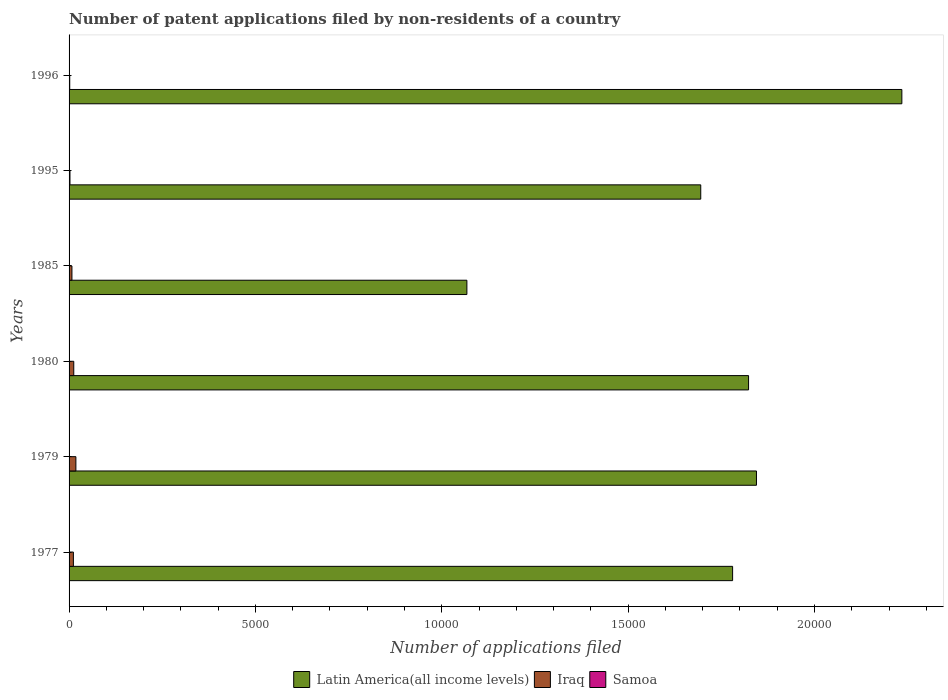Are the number of bars on each tick of the Y-axis equal?
Offer a very short reply. Yes. How many bars are there on the 6th tick from the top?
Make the answer very short. 3. What is the label of the 4th group of bars from the top?
Offer a very short reply. 1980. What is the number of applications filed in Iraq in 1980?
Ensure brevity in your answer.  126. In which year was the number of applications filed in Samoa maximum?
Your answer should be very brief. 1979. What is the total number of applications filed in Latin America(all income levels) in the graph?
Offer a very short reply. 1.04e+05. What is the difference between the number of applications filed in Iraq in 1977 and the number of applications filed in Latin America(all income levels) in 1995?
Your answer should be very brief. -1.68e+04. What is the average number of applications filed in Iraq per year?
Your answer should be very brief. 90.67. In the year 1995, what is the difference between the number of applications filed in Iraq and number of applications filed in Samoa?
Ensure brevity in your answer.  22. In how many years, is the number of applications filed in Samoa greater than 13000 ?
Ensure brevity in your answer.  0. What is the difference between the highest and the second highest number of applications filed in Samoa?
Offer a very short reply. 0. What is the difference between the highest and the lowest number of applications filed in Iraq?
Ensure brevity in your answer.  165. Is the sum of the number of applications filed in Iraq in 1979 and 1980 greater than the maximum number of applications filed in Samoa across all years?
Offer a very short reply. Yes. What does the 3rd bar from the top in 1977 represents?
Offer a very short reply. Latin America(all income levels). What does the 1st bar from the bottom in 1985 represents?
Offer a very short reply. Latin America(all income levels). How many bars are there?
Provide a short and direct response. 18. Are all the bars in the graph horizontal?
Provide a succinct answer. Yes. How many years are there in the graph?
Keep it short and to the point. 6. What is the title of the graph?
Give a very brief answer. Number of patent applications filed by non-residents of a country. What is the label or title of the X-axis?
Make the answer very short. Number of applications filed. What is the label or title of the Y-axis?
Offer a terse response. Years. What is the Number of applications filed in Latin America(all income levels) in 1977?
Provide a succinct answer. 1.78e+04. What is the Number of applications filed of Iraq in 1977?
Your answer should be compact. 116. What is the Number of applications filed in Latin America(all income levels) in 1979?
Make the answer very short. 1.84e+04. What is the Number of applications filed in Iraq in 1979?
Provide a short and direct response. 183. What is the Number of applications filed in Latin America(all income levels) in 1980?
Your answer should be compact. 1.82e+04. What is the Number of applications filed of Iraq in 1980?
Your response must be concise. 126. What is the Number of applications filed of Samoa in 1980?
Give a very brief answer. 2. What is the Number of applications filed of Latin America(all income levels) in 1985?
Provide a succinct answer. 1.07e+04. What is the Number of applications filed in Iraq in 1985?
Your answer should be very brief. 77. What is the Number of applications filed in Latin America(all income levels) in 1995?
Keep it short and to the point. 1.69e+04. What is the Number of applications filed of Iraq in 1995?
Give a very brief answer. 24. What is the Number of applications filed of Latin America(all income levels) in 1996?
Make the answer very short. 2.23e+04. Across all years, what is the maximum Number of applications filed in Latin America(all income levels)?
Your response must be concise. 2.23e+04. Across all years, what is the maximum Number of applications filed of Iraq?
Give a very brief answer. 183. Across all years, what is the maximum Number of applications filed of Samoa?
Offer a terse response. 4. Across all years, what is the minimum Number of applications filed in Latin America(all income levels)?
Provide a short and direct response. 1.07e+04. Across all years, what is the minimum Number of applications filed in Iraq?
Ensure brevity in your answer.  18. Across all years, what is the minimum Number of applications filed of Samoa?
Provide a short and direct response. 2. What is the total Number of applications filed in Latin America(all income levels) in the graph?
Provide a succinct answer. 1.04e+05. What is the total Number of applications filed of Iraq in the graph?
Your response must be concise. 544. What is the total Number of applications filed of Samoa in the graph?
Your answer should be very brief. 18. What is the difference between the Number of applications filed of Latin America(all income levels) in 1977 and that in 1979?
Offer a terse response. -640. What is the difference between the Number of applications filed of Iraq in 1977 and that in 1979?
Provide a succinct answer. -67. What is the difference between the Number of applications filed of Samoa in 1977 and that in 1979?
Provide a succinct answer. -1. What is the difference between the Number of applications filed in Latin America(all income levels) in 1977 and that in 1980?
Make the answer very short. -428. What is the difference between the Number of applications filed in Samoa in 1977 and that in 1980?
Give a very brief answer. 1. What is the difference between the Number of applications filed in Latin America(all income levels) in 1977 and that in 1985?
Offer a very short reply. 7130. What is the difference between the Number of applications filed of Iraq in 1977 and that in 1985?
Ensure brevity in your answer.  39. What is the difference between the Number of applications filed of Latin America(all income levels) in 1977 and that in 1995?
Your response must be concise. 855. What is the difference between the Number of applications filed of Iraq in 1977 and that in 1995?
Give a very brief answer. 92. What is the difference between the Number of applications filed in Samoa in 1977 and that in 1995?
Provide a short and direct response. 1. What is the difference between the Number of applications filed in Latin America(all income levels) in 1977 and that in 1996?
Ensure brevity in your answer.  -4541. What is the difference between the Number of applications filed in Latin America(all income levels) in 1979 and that in 1980?
Give a very brief answer. 212. What is the difference between the Number of applications filed of Samoa in 1979 and that in 1980?
Your answer should be compact. 2. What is the difference between the Number of applications filed of Latin America(all income levels) in 1979 and that in 1985?
Your response must be concise. 7770. What is the difference between the Number of applications filed in Iraq in 1979 and that in 1985?
Your answer should be very brief. 106. What is the difference between the Number of applications filed in Samoa in 1979 and that in 1985?
Your answer should be compact. 0. What is the difference between the Number of applications filed of Latin America(all income levels) in 1979 and that in 1995?
Give a very brief answer. 1495. What is the difference between the Number of applications filed of Iraq in 1979 and that in 1995?
Your response must be concise. 159. What is the difference between the Number of applications filed in Latin America(all income levels) in 1979 and that in 1996?
Your answer should be very brief. -3901. What is the difference between the Number of applications filed in Iraq in 1979 and that in 1996?
Provide a succinct answer. 165. What is the difference between the Number of applications filed in Latin America(all income levels) in 1980 and that in 1985?
Provide a succinct answer. 7558. What is the difference between the Number of applications filed of Samoa in 1980 and that in 1985?
Your answer should be very brief. -2. What is the difference between the Number of applications filed of Latin America(all income levels) in 1980 and that in 1995?
Offer a very short reply. 1283. What is the difference between the Number of applications filed of Iraq in 1980 and that in 1995?
Your answer should be compact. 102. What is the difference between the Number of applications filed of Samoa in 1980 and that in 1995?
Keep it short and to the point. 0. What is the difference between the Number of applications filed in Latin America(all income levels) in 1980 and that in 1996?
Offer a terse response. -4113. What is the difference between the Number of applications filed in Iraq in 1980 and that in 1996?
Give a very brief answer. 108. What is the difference between the Number of applications filed in Samoa in 1980 and that in 1996?
Provide a succinct answer. -1. What is the difference between the Number of applications filed of Latin America(all income levels) in 1985 and that in 1995?
Your response must be concise. -6275. What is the difference between the Number of applications filed of Iraq in 1985 and that in 1995?
Your answer should be very brief. 53. What is the difference between the Number of applications filed of Latin America(all income levels) in 1985 and that in 1996?
Ensure brevity in your answer.  -1.17e+04. What is the difference between the Number of applications filed of Iraq in 1985 and that in 1996?
Give a very brief answer. 59. What is the difference between the Number of applications filed of Latin America(all income levels) in 1995 and that in 1996?
Your response must be concise. -5396. What is the difference between the Number of applications filed in Iraq in 1995 and that in 1996?
Provide a short and direct response. 6. What is the difference between the Number of applications filed of Samoa in 1995 and that in 1996?
Provide a succinct answer. -1. What is the difference between the Number of applications filed in Latin America(all income levels) in 1977 and the Number of applications filed in Iraq in 1979?
Keep it short and to the point. 1.76e+04. What is the difference between the Number of applications filed in Latin America(all income levels) in 1977 and the Number of applications filed in Samoa in 1979?
Offer a terse response. 1.78e+04. What is the difference between the Number of applications filed of Iraq in 1977 and the Number of applications filed of Samoa in 1979?
Ensure brevity in your answer.  112. What is the difference between the Number of applications filed of Latin America(all income levels) in 1977 and the Number of applications filed of Iraq in 1980?
Offer a terse response. 1.77e+04. What is the difference between the Number of applications filed of Latin America(all income levels) in 1977 and the Number of applications filed of Samoa in 1980?
Ensure brevity in your answer.  1.78e+04. What is the difference between the Number of applications filed of Iraq in 1977 and the Number of applications filed of Samoa in 1980?
Provide a short and direct response. 114. What is the difference between the Number of applications filed of Latin America(all income levels) in 1977 and the Number of applications filed of Iraq in 1985?
Offer a terse response. 1.77e+04. What is the difference between the Number of applications filed of Latin America(all income levels) in 1977 and the Number of applications filed of Samoa in 1985?
Your answer should be compact. 1.78e+04. What is the difference between the Number of applications filed in Iraq in 1977 and the Number of applications filed in Samoa in 1985?
Provide a short and direct response. 112. What is the difference between the Number of applications filed of Latin America(all income levels) in 1977 and the Number of applications filed of Iraq in 1995?
Provide a succinct answer. 1.78e+04. What is the difference between the Number of applications filed of Latin America(all income levels) in 1977 and the Number of applications filed of Samoa in 1995?
Give a very brief answer. 1.78e+04. What is the difference between the Number of applications filed in Iraq in 1977 and the Number of applications filed in Samoa in 1995?
Keep it short and to the point. 114. What is the difference between the Number of applications filed of Latin America(all income levels) in 1977 and the Number of applications filed of Iraq in 1996?
Provide a short and direct response. 1.78e+04. What is the difference between the Number of applications filed in Latin America(all income levels) in 1977 and the Number of applications filed in Samoa in 1996?
Offer a very short reply. 1.78e+04. What is the difference between the Number of applications filed of Iraq in 1977 and the Number of applications filed of Samoa in 1996?
Your answer should be very brief. 113. What is the difference between the Number of applications filed of Latin America(all income levels) in 1979 and the Number of applications filed of Iraq in 1980?
Your answer should be very brief. 1.83e+04. What is the difference between the Number of applications filed in Latin America(all income levels) in 1979 and the Number of applications filed in Samoa in 1980?
Provide a succinct answer. 1.84e+04. What is the difference between the Number of applications filed of Iraq in 1979 and the Number of applications filed of Samoa in 1980?
Your answer should be very brief. 181. What is the difference between the Number of applications filed of Latin America(all income levels) in 1979 and the Number of applications filed of Iraq in 1985?
Your response must be concise. 1.84e+04. What is the difference between the Number of applications filed in Latin America(all income levels) in 1979 and the Number of applications filed in Samoa in 1985?
Your answer should be compact. 1.84e+04. What is the difference between the Number of applications filed of Iraq in 1979 and the Number of applications filed of Samoa in 1985?
Make the answer very short. 179. What is the difference between the Number of applications filed in Latin America(all income levels) in 1979 and the Number of applications filed in Iraq in 1995?
Offer a very short reply. 1.84e+04. What is the difference between the Number of applications filed in Latin America(all income levels) in 1979 and the Number of applications filed in Samoa in 1995?
Give a very brief answer. 1.84e+04. What is the difference between the Number of applications filed of Iraq in 1979 and the Number of applications filed of Samoa in 1995?
Provide a short and direct response. 181. What is the difference between the Number of applications filed in Latin America(all income levels) in 1979 and the Number of applications filed in Iraq in 1996?
Give a very brief answer. 1.84e+04. What is the difference between the Number of applications filed in Latin America(all income levels) in 1979 and the Number of applications filed in Samoa in 1996?
Give a very brief answer. 1.84e+04. What is the difference between the Number of applications filed in Iraq in 1979 and the Number of applications filed in Samoa in 1996?
Ensure brevity in your answer.  180. What is the difference between the Number of applications filed of Latin America(all income levels) in 1980 and the Number of applications filed of Iraq in 1985?
Your answer should be very brief. 1.82e+04. What is the difference between the Number of applications filed in Latin America(all income levels) in 1980 and the Number of applications filed in Samoa in 1985?
Offer a terse response. 1.82e+04. What is the difference between the Number of applications filed of Iraq in 1980 and the Number of applications filed of Samoa in 1985?
Provide a succinct answer. 122. What is the difference between the Number of applications filed of Latin America(all income levels) in 1980 and the Number of applications filed of Iraq in 1995?
Offer a terse response. 1.82e+04. What is the difference between the Number of applications filed of Latin America(all income levels) in 1980 and the Number of applications filed of Samoa in 1995?
Offer a very short reply. 1.82e+04. What is the difference between the Number of applications filed of Iraq in 1980 and the Number of applications filed of Samoa in 1995?
Your answer should be compact. 124. What is the difference between the Number of applications filed of Latin America(all income levels) in 1980 and the Number of applications filed of Iraq in 1996?
Your response must be concise. 1.82e+04. What is the difference between the Number of applications filed in Latin America(all income levels) in 1980 and the Number of applications filed in Samoa in 1996?
Provide a succinct answer. 1.82e+04. What is the difference between the Number of applications filed in Iraq in 1980 and the Number of applications filed in Samoa in 1996?
Offer a very short reply. 123. What is the difference between the Number of applications filed in Latin America(all income levels) in 1985 and the Number of applications filed in Iraq in 1995?
Provide a succinct answer. 1.06e+04. What is the difference between the Number of applications filed of Latin America(all income levels) in 1985 and the Number of applications filed of Samoa in 1995?
Provide a short and direct response. 1.07e+04. What is the difference between the Number of applications filed of Latin America(all income levels) in 1985 and the Number of applications filed of Iraq in 1996?
Ensure brevity in your answer.  1.07e+04. What is the difference between the Number of applications filed in Latin America(all income levels) in 1985 and the Number of applications filed in Samoa in 1996?
Provide a succinct answer. 1.07e+04. What is the difference between the Number of applications filed in Latin America(all income levels) in 1995 and the Number of applications filed in Iraq in 1996?
Your answer should be very brief. 1.69e+04. What is the difference between the Number of applications filed of Latin America(all income levels) in 1995 and the Number of applications filed of Samoa in 1996?
Offer a very short reply. 1.69e+04. What is the difference between the Number of applications filed of Iraq in 1995 and the Number of applications filed of Samoa in 1996?
Offer a terse response. 21. What is the average Number of applications filed of Latin America(all income levels) per year?
Offer a very short reply. 1.74e+04. What is the average Number of applications filed of Iraq per year?
Ensure brevity in your answer.  90.67. In the year 1977, what is the difference between the Number of applications filed in Latin America(all income levels) and Number of applications filed in Iraq?
Provide a succinct answer. 1.77e+04. In the year 1977, what is the difference between the Number of applications filed in Latin America(all income levels) and Number of applications filed in Samoa?
Provide a short and direct response. 1.78e+04. In the year 1977, what is the difference between the Number of applications filed in Iraq and Number of applications filed in Samoa?
Your answer should be very brief. 113. In the year 1979, what is the difference between the Number of applications filed in Latin America(all income levels) and Number of applications filed in Iraq?
Your answer should be compact. 1.83e+04. In the year 1979, what is the difference between the Number of applications filed in Latin America(all income levels) and Number of applications filed in Samoa?
Your answer should be compact. 1.84e+04. In the year 1979, what is the difference between the Number of applications filed in Iraq and Number of applications filed in Samoa?
Offer a terse response. 179. In the year 1980, what is the difference between the Number of applications filed in Latin America(all income levels) and Number of applications filed in Iraq?
Provide a succinct answer. 1.81e+04. In the year 1980, what is the difference between the Number of applications filed in Latin America(all income levels) and Number of applications filed in Samoa?
Offer a very short reply. 1.82e+04. In the year 1980, what is the difference between the Number of applications filed of Iraq and Number of applications filed of Samoa?
Ensure brevity in your answer.  124. In the year 1985, what is the difference between the Number of applications filed of Latin America(all income levels) and Number of applications filed of Iraq?
Give a very brief answer. 1.06e+04. In the year 1985, what is the difference between the Number of applications filed in Latin America(all income levels) and Number of applications filed in Samoa?
Offer a very short reply. 1.07e+04. In the year 1985, what is the difference between the Number of applications filed of Iraq and Number of applications filed of Samoa?
Your response must be concise. 73. In the year 1995, what is the difference between the Number of applications filed of Latin America(all income levels) and Number of applications filed of Iraq?
Your answer should be compact. 1.69e+04. In the year 1995, what is the difference between the Number of applications filed of Latin America(all income levels) and Number of applications filed of Samoa?
Your answer should be very brief. 1.69e+04. In the year 1995, what is the difference between the Number of applications filed in Iraq and Number of applications filed in Samoa?
Your answer should be compact. 22. In the year 1996, what is the difference between the Number of applications filed in Latin America(all income levels) and Number of applications filed in Iraq?
Your answer should be very brief. 2.23e+04. In the year 1996, what is the difference between the Number of applications filed in Latin America(all income levels) and Number of applications filed in Samoa?
Offer a very short reply. 2.23e+04. What is the ratio of the Number of applications filed in Latin America(all income levels) in 1977 to that in 1979?
Provide a succinct answer. 0.97. What is the ratio of the Number of applications filed in Iraq in 1977 to that in 1979?
Keep it short and to the point. 0.63. What is the ratio of the Number of applications filed in Latin America(all income levels) in 1977 to that in 1980?
Give a very brief answer. 0.98. What is the ratio of the Number of applications filed in Iraq in 1977 to that in 1980?
Offer a terse response. 0.92. What is the ratio of the Number of applications filed of Samoa in 1977 to that in 1980?
Ensure brevity in your answer.  1.5. What is the ratio of the Number of applications filed in Latin America(all income levels) in 1977 to that in 1985?
Offer a terse response. 1.67. What is the ratio of the Number of applications filed of Iraq in 1977 to that in 1985?
Provide a short and direct response. 1.51. What is the ratio of the Number of applications filed of Latin America(all income levels) in 1977 to that in 1995?
Make the answer very short. 1.05. What is the ratio of the Number of applications filed in Iraq in 1977 to that in 1995?
Your response must be concise. 4.83. What is the ratio of the Number of applications filed of Samoa in 1977 to that in 1995?
Provide a short and direct response. 1.5. What is the ratio of the Number of applications filed in Latin America(all income levels) in 1977 to that in 1996?
Your answer should be very brief. 0.8. What is the ratio of the Number of applications filed in Iraq in 1977 to that in 1996?
Ensure brevity in your answer.  6.44. What is the ratio of the Number of applications filed in Latin America(all income levels) in 1979 to that in 1980?
Offer a terse response. 1.01. What is the ratio of the Number of applications filed in Iraq in 1979 to that in 1980?
Give a very brief answer. 1.45. What is the ratio of the Number of applications filed of Latin America(all income levels) in 1979 to that in 1985?
Your response must be concise. 1.73. What is the ratio of the Number of applications filed in Iraq in 1979 to that in 1985?
Give a very brief answer. 2.38. What is the ratio of the Number of applications filed in Latin America(all income levels) in 1979 to that in 1995?
Make the answer very short. 1.09. What is the ratio of the Number of applications filed in Iraq in 1979 to that in 1995?
Your answer should be very brief. 7.62. What is the ratio of the Number of applications filed in Latin America(all income levels) in 1979 to that in 1996?
Your answer should be compact. 0.83. What is the ratio of the Number of applications filed in Iraq in 1979 to that in 1996?
Provide a short and direct response. 10.17. What is the ratio of the Number of applications filed of Samoa in 1979 to that in 1996?
Your answer should be compact. 1.33. What is the ratio of the Number of applications filed in Latin America(all income levels) in 1980 to that in 1985?
Make the answer very short. 1.71. What is the ratio of the Number of applications filed in Iraq in 1980 to that in 1985?
Provide a short and direct response. 1.64. What is the ratio of the Number of applications filed in Latin America(all income levels) in 1980 to that in 1995?
Provide a succinct answer. 1.08. What is the ratio of the Number of applications filed in Iraq in 1980 to that in 1995?
Provide a short and direct response. 5.25. What is the ratio of the Number of applications filed in Samoa in 1980 to that in 1995?
Your answer should be very brief. 1. What is the ratio of the Number of applications filed in Latin America(all income levels) in 1980 to that in 1996?
Your response must be concise. 0.82. What is the ratio of the Number of applications filed of Iraq in 1980 to that in 1996?
Offer a very short reply. 7. What is the ratio of the Number of applications filed of Latin America(all income levels) in 1985 to that in 1995?
Your answer should be very brief. 0.63. What is the ratio of the Number of applications filed in Iraq in 1985 to that in 1995?
Provide a short and direct response. 3.21. What is the ratio of the Number of applications filed in Latin America(all income levels) in 1985 to that in 1996?
Your answer should be very brief. 0.48. What is the ratio of the Number of applications filed in Iraq in 1985 to that in 1996?
Your answer should be compact. 4.28. What is the ratio of the Number of applications filed of Samoa in 1985 to that in 1996?
Ensure brevity in your answer.  1.33. What is the ratio of the Number of applications filed in Latin America(all income levels) in 1995 to that in 1996?
Give a very brief answer. 0.76. What is the ratio of the Number of applications filed in Samoa in 1995 to that in 1996?
Your answer should be very brief. 0.67. What is the difference between the highest and the second highest Number of applications filed in Latin America(all income levels)?
Your answer should be compact. 3901. What is the difference between the highest and the second highest Number of applications filed in Iraq?
Keep it short and to the point. 57. What is the difference between the highest and the second highest Number of applications filed of Samoa?
Make the answer very short. 0. What is the difference between the highest and the lowest Number of applications filed in Latin America(all income levels)?
Ensure brevity in your answer.  1.17e+04. What is the difference between the highest and the lowest Number of applications filed in Iraq?
Your answer should be very brief. 165. 